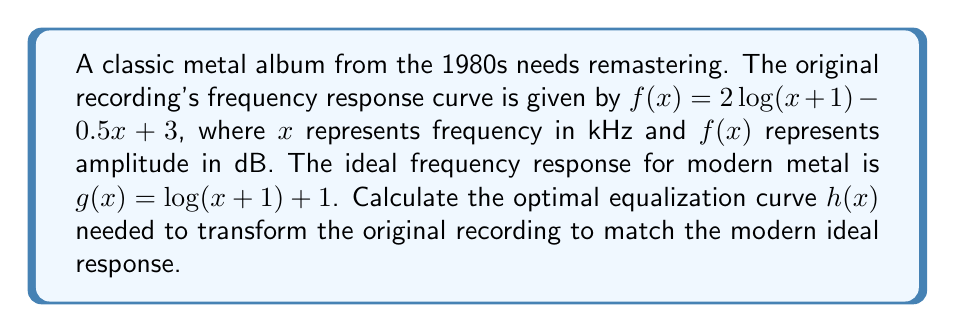Could you help me with this problem? To find the optimal equalization curve, we need to determine the function $h(x)$ that, when added to the original curve $f(x)$, results in the ideal curve $g(x)$. This can be represented as:

$f(x) + h(x) = g(x)$

Therefore, we can solve for $h(x)$:

$h(x) = g(x) - f(x)$

Step 1: Substitute the given functions
$h(x) = [\log(x+1) + 1] - [2\log(x+1) - 0.5x + 3]$

Step 2: Simplify
$h(x) = \log(x+1) + 1 - 2\log(x+1) + 0.5x - 3$
$h(x) = -\log(x+1) + 0.5x - 2$

Step 3: Combine like terms
The final equalization curve is:
$h(x) = 0.5x - \log(x+1) - 2$

This function represents the dB adjustment needed at each frequency $x$ (in kHz) to transform the original recording to match the modern ideal response.
Answer: $h(x) = 0.5x - \log(x+1) - 2$ 